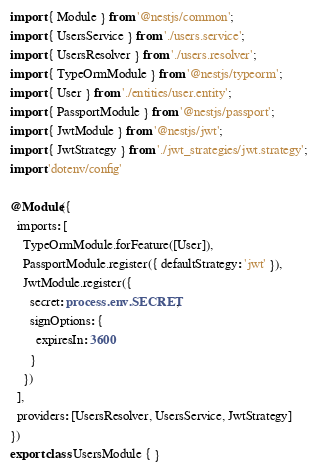Convert code to text. <code><loc_0><loc_0><loc_500><loc_500><_TypeScript_>import { Module } from '@nestjs/common';
import { UsersService } from './users.service';
import { UsersResolver } from './users.resolver';
import { TypeOrmModule } from '@nestjs/typeorm';
import { User } from './entities/user.entity';
import { PassportModule } from '@nestjs/passport';
import { JwtModule } from '@nestjs/jwt';
import { JwtStrategy } from './jwt_strategies/jwt.strategy';
import 'dotenv/config'

@Module({
  imports: [
    TypeOrmModule.forFeature([User]),
    PassportModule.register({ defaultStrategy: 'jwt' }),
    JwtModule.register({
      secret: process.env.SECRET,
      signOptions: {
        expiresIn: 3600
      }
    })
  ],
  providers: [UsersResolver, UsersService, JwtStrategy]
})
export class UsersModule { }
</code> 